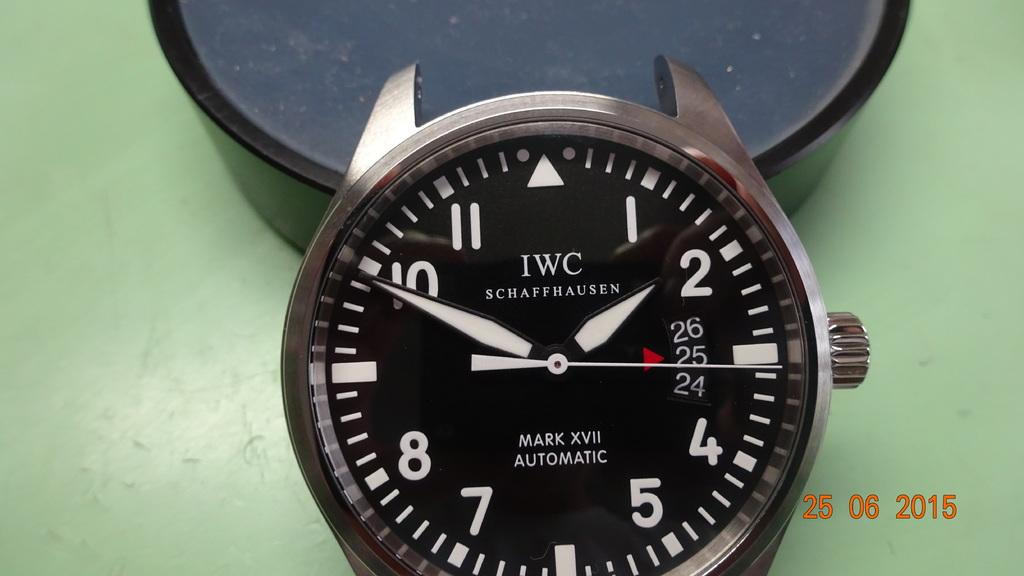Provide a one-sentence caption for the provided image. a IWC watch head that is black and silver. 